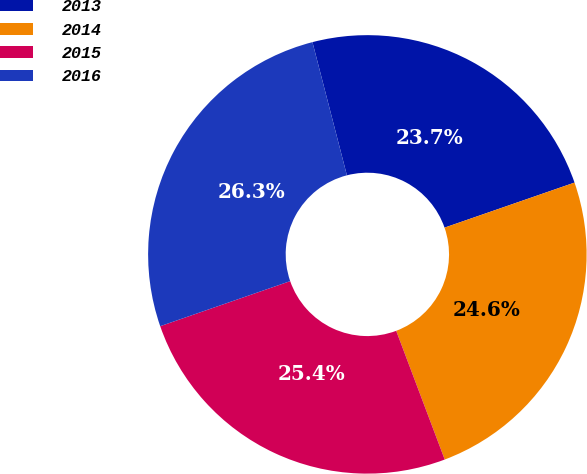Convert chart to OTSL. <chart><loc_0><loc_0><loc_500><loc_500><pie_chart><fcel>2013<fcel>2014<fcel>2015<fcel>2016<nl><fcel>23.72%<fcel>24.57%<fcel>25.43%<fcel>26.28%<nl></chart> 